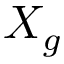Convert formula to latex. <formula><loc_0><loc_0><loc_500><loc_500>X _ { g }</formula> 